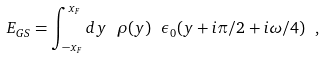Convert formula to latex. <formula><loc_0><loc_0><loc_500><loc_500>E _ { G S } = \int _ { - x _ { F } } ^ { x _ { F } } d y \ \rho ( y ) \ \epsilon _ { 0 } ( y + i \pi / 2 + i \omega / 4 ) \ ,</formula> 